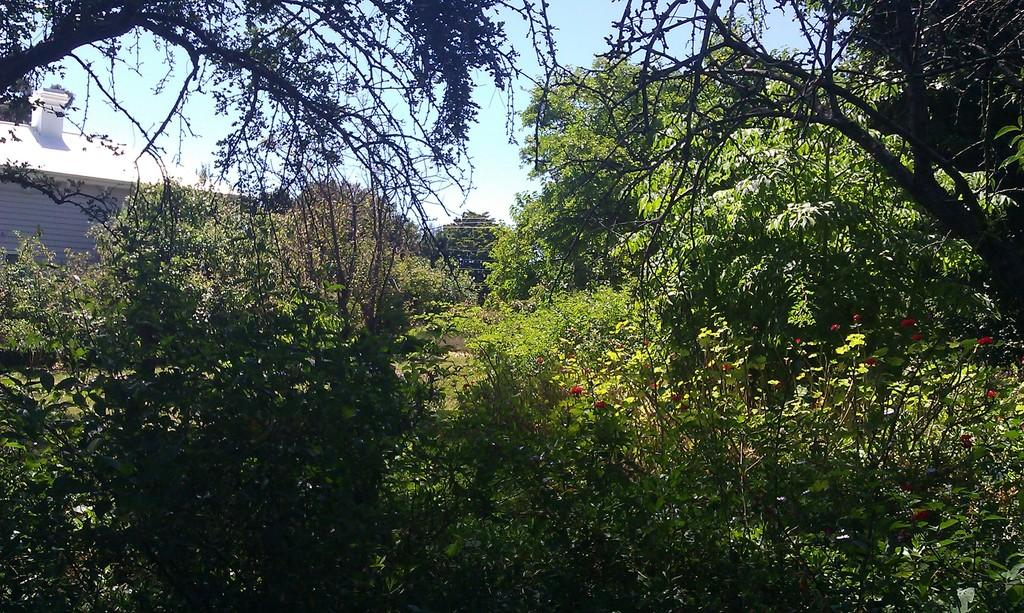What type of vegetation can be seen in the image? There are plants, flowers, and trees in the image. What structure is visible in the background of the image? There is a house in the background of the image. What is visible in the sky in the image? The sky is visible in the background of the image. How do the babies react to the plants in the image? There are no babies present in the image, so it is not possible to determine their reaction to the plants. 